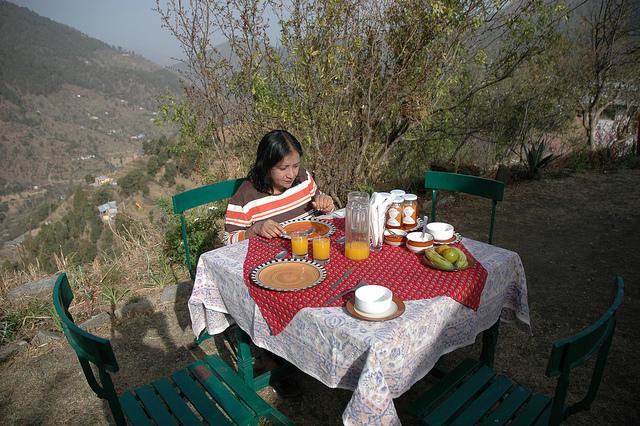Is the girl outside?
Quick response, please. Yes. What color is the tablecloth?
Answer briefly. White. What meal is the girl eating?
Short answer required. Breakfast. What is the food with the metal rings?
Concise answer only. Fruit. 